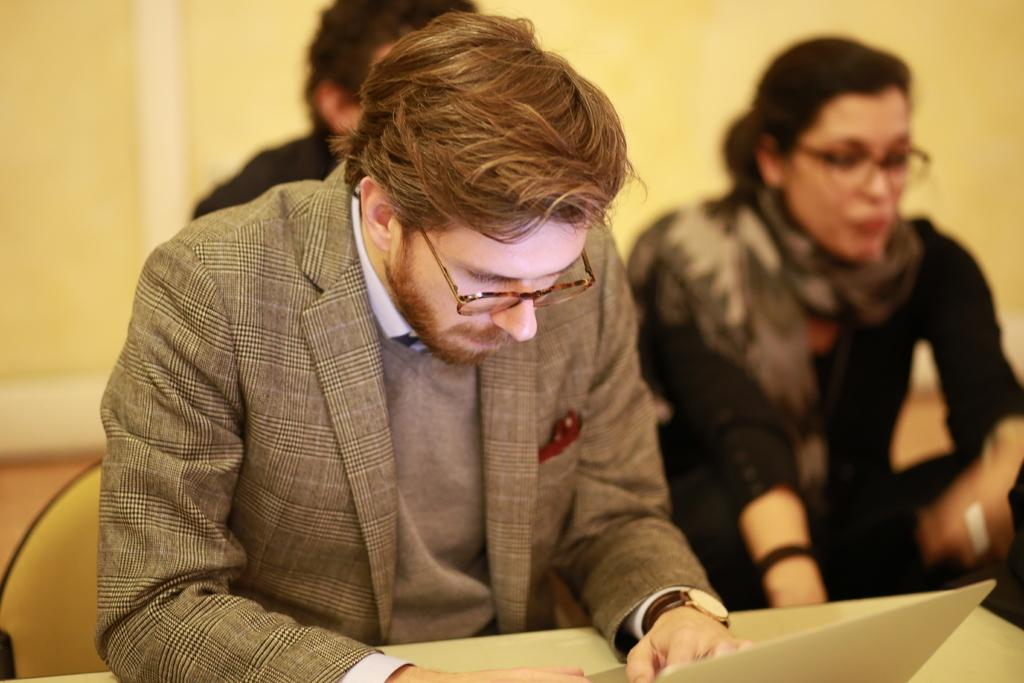What are the people in the image doing? There are people sitting in the image. Can you describe what one person is doing specifically? One person is working on a laptop. Is the person's grandmother saying good-bye to them in the image? There is no indication of a grandmother or anyone saying good-bye in the image. 